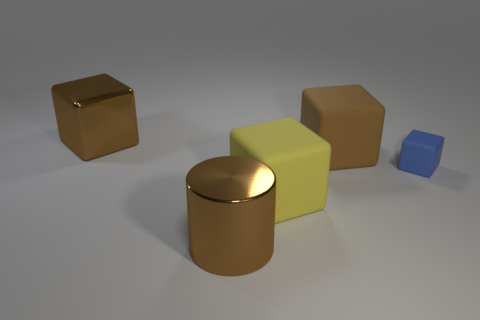There is a large cylinder that is the same color as the big metal cube; what is its material?
Provide a short and direct response. Metal. There is another block that is the same color as the shiny cube; what size is it?
Offer a very short reply. Large. Are there fewer rubber things behind the large yellow cube than big cubes that are to the left of the brown metal block?
Provide a short and direct response. No. Is the big cylinder made of the same material as the block in front of the small blue matte object?
Your response must be concise. No. Is there any other thing that has the same material as the big cylinder?
Offer a terse response. Yes. Are there more metal objects than matte spheres?
Ensure brevity in your answer.  Yes. What shape is the large brown shiny thing to the right of the big brown thing on the left side of the big cylinder that is on the left side of the tiny matte thing?
Make the answer very short. Cylinder. Is the material of the big brown object right of the big shiny cylinder the same as the cube that is in front of the blue block?
Keep it short and to the point. Yes. What is the shape of the other yellow thing that is the same material as the small thing?
Provide a succinct answer. Cube. Is there any other thing of the same color as the small object?
Provide a short and direct response. No. 